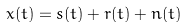Convert formula to latex. <formula><loc_0><loc_0><loc_500><loc_500>x ( t ) = s ( t ) + r ( t ) + n ( t )</formula> 